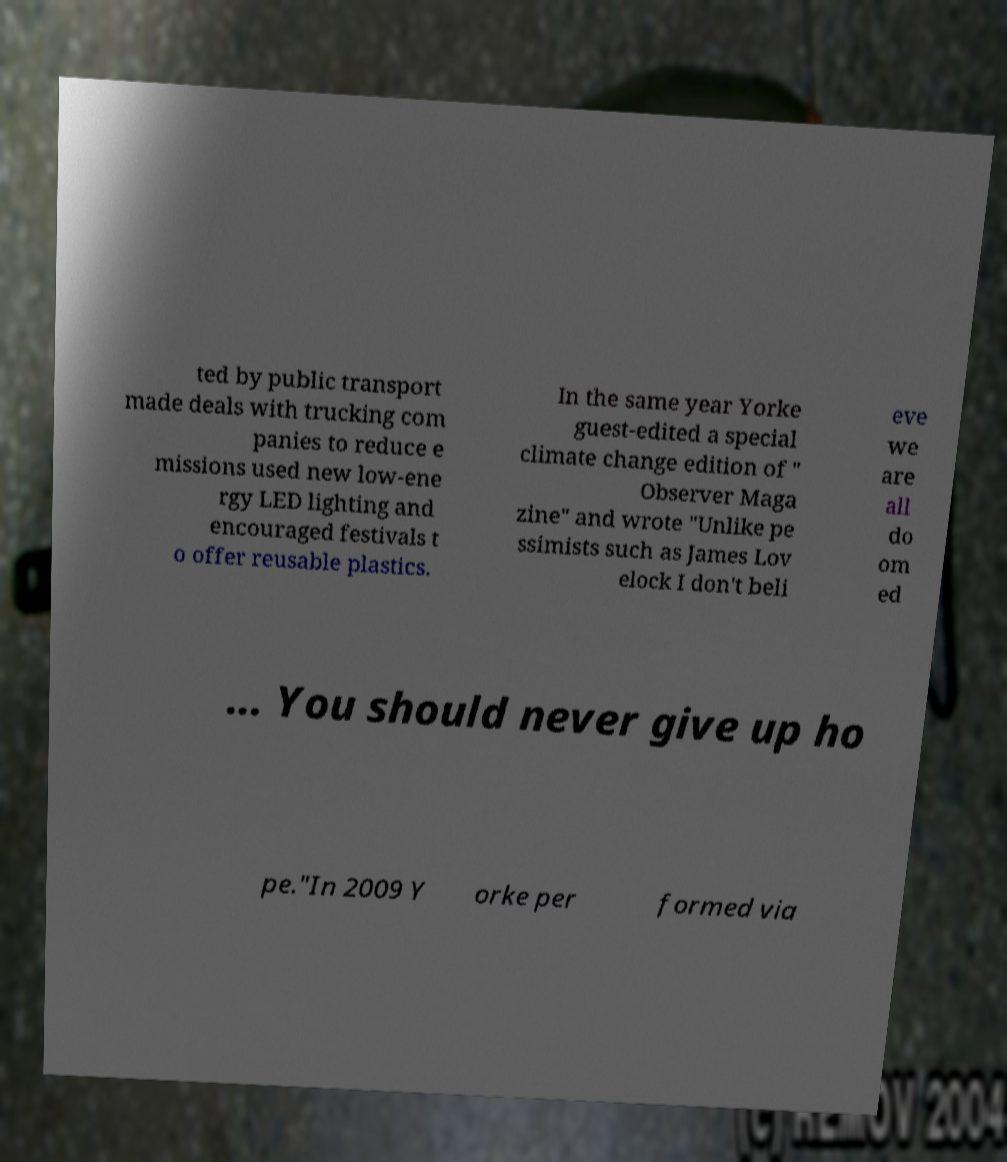Please read and relay the text visible in this image. What does it say? ted by public transport made deals with trucking com panies to reduce e missions used new low-ene rgy LED lighting and encouraged festivals t o offer reusable plastics. In the same year Yorke guest-edited a special climate change edition of " Observer Maga zine" and wrote "Unlike pe ssimists such as James Lov elock I don't beli eve we are all do om ed ... You should never give up ho pe."In 2009 Y orke per formed via 